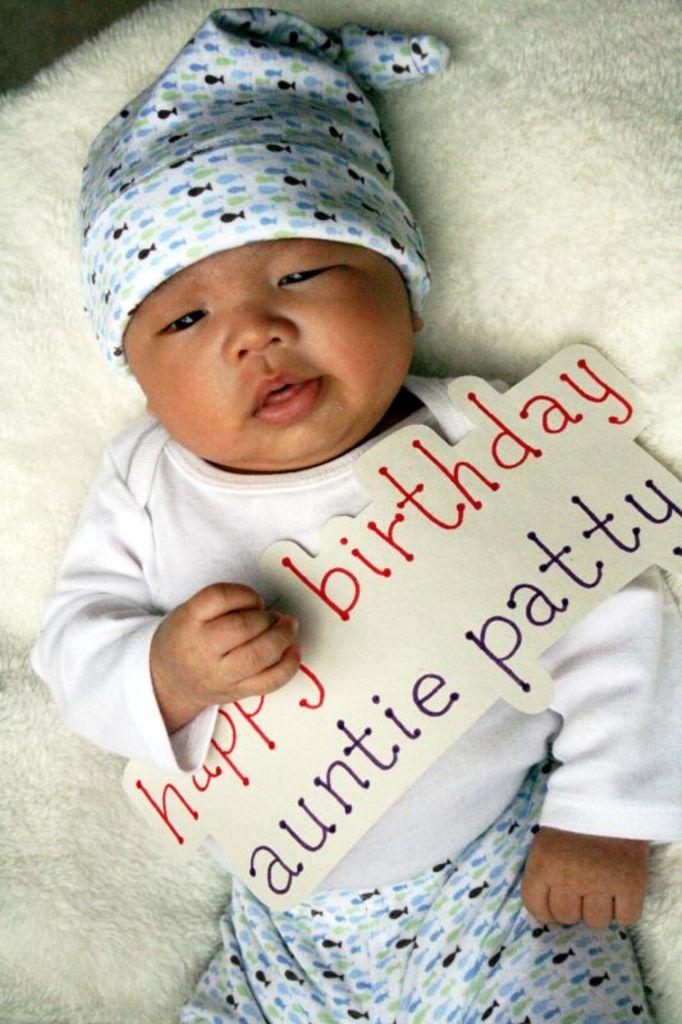In one or two sentences, can you explain what this image depicts? In the picture I can see a child is lying on a white color cloth. The child is wearing a cap and holding a paper which has something written on it. 